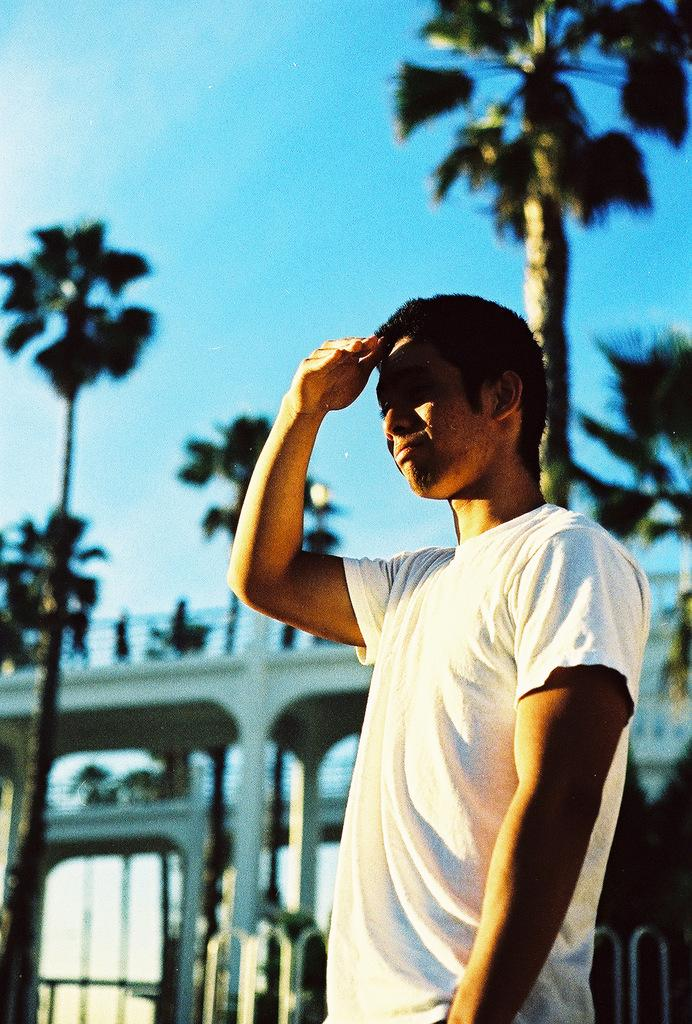What is the main subject of the image? There is a person standing in the center of the image. What can be seen in the background of the image? The sky, clouds, trees, people, and a bridge are visible in the background of the image. Can you describe the sky in the image? The sky is visible in the background of the image. What type of juice is being served on the bridge in the image? There is no juice or bridge present in the image; it features a person standing in the center and various elements in the background. 